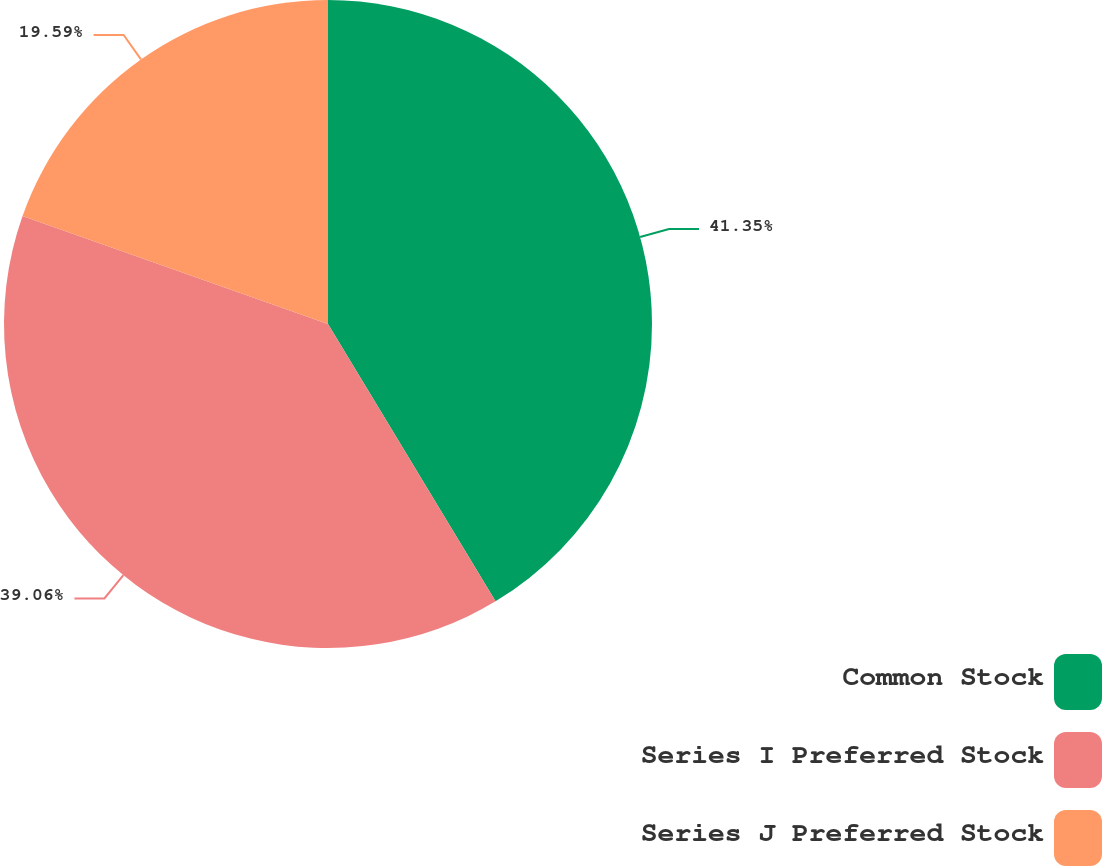Convert chart. <chart><loc_0><loc_0><loc_500><loc_500><pie_chart><fcel>Common Stock<fcel>Series I Preferred Stock<fcel>Series J Preferred Stock<nl><fcel>41.35%<fcel>39.06%<fcel>19.59%<nl></chart> 